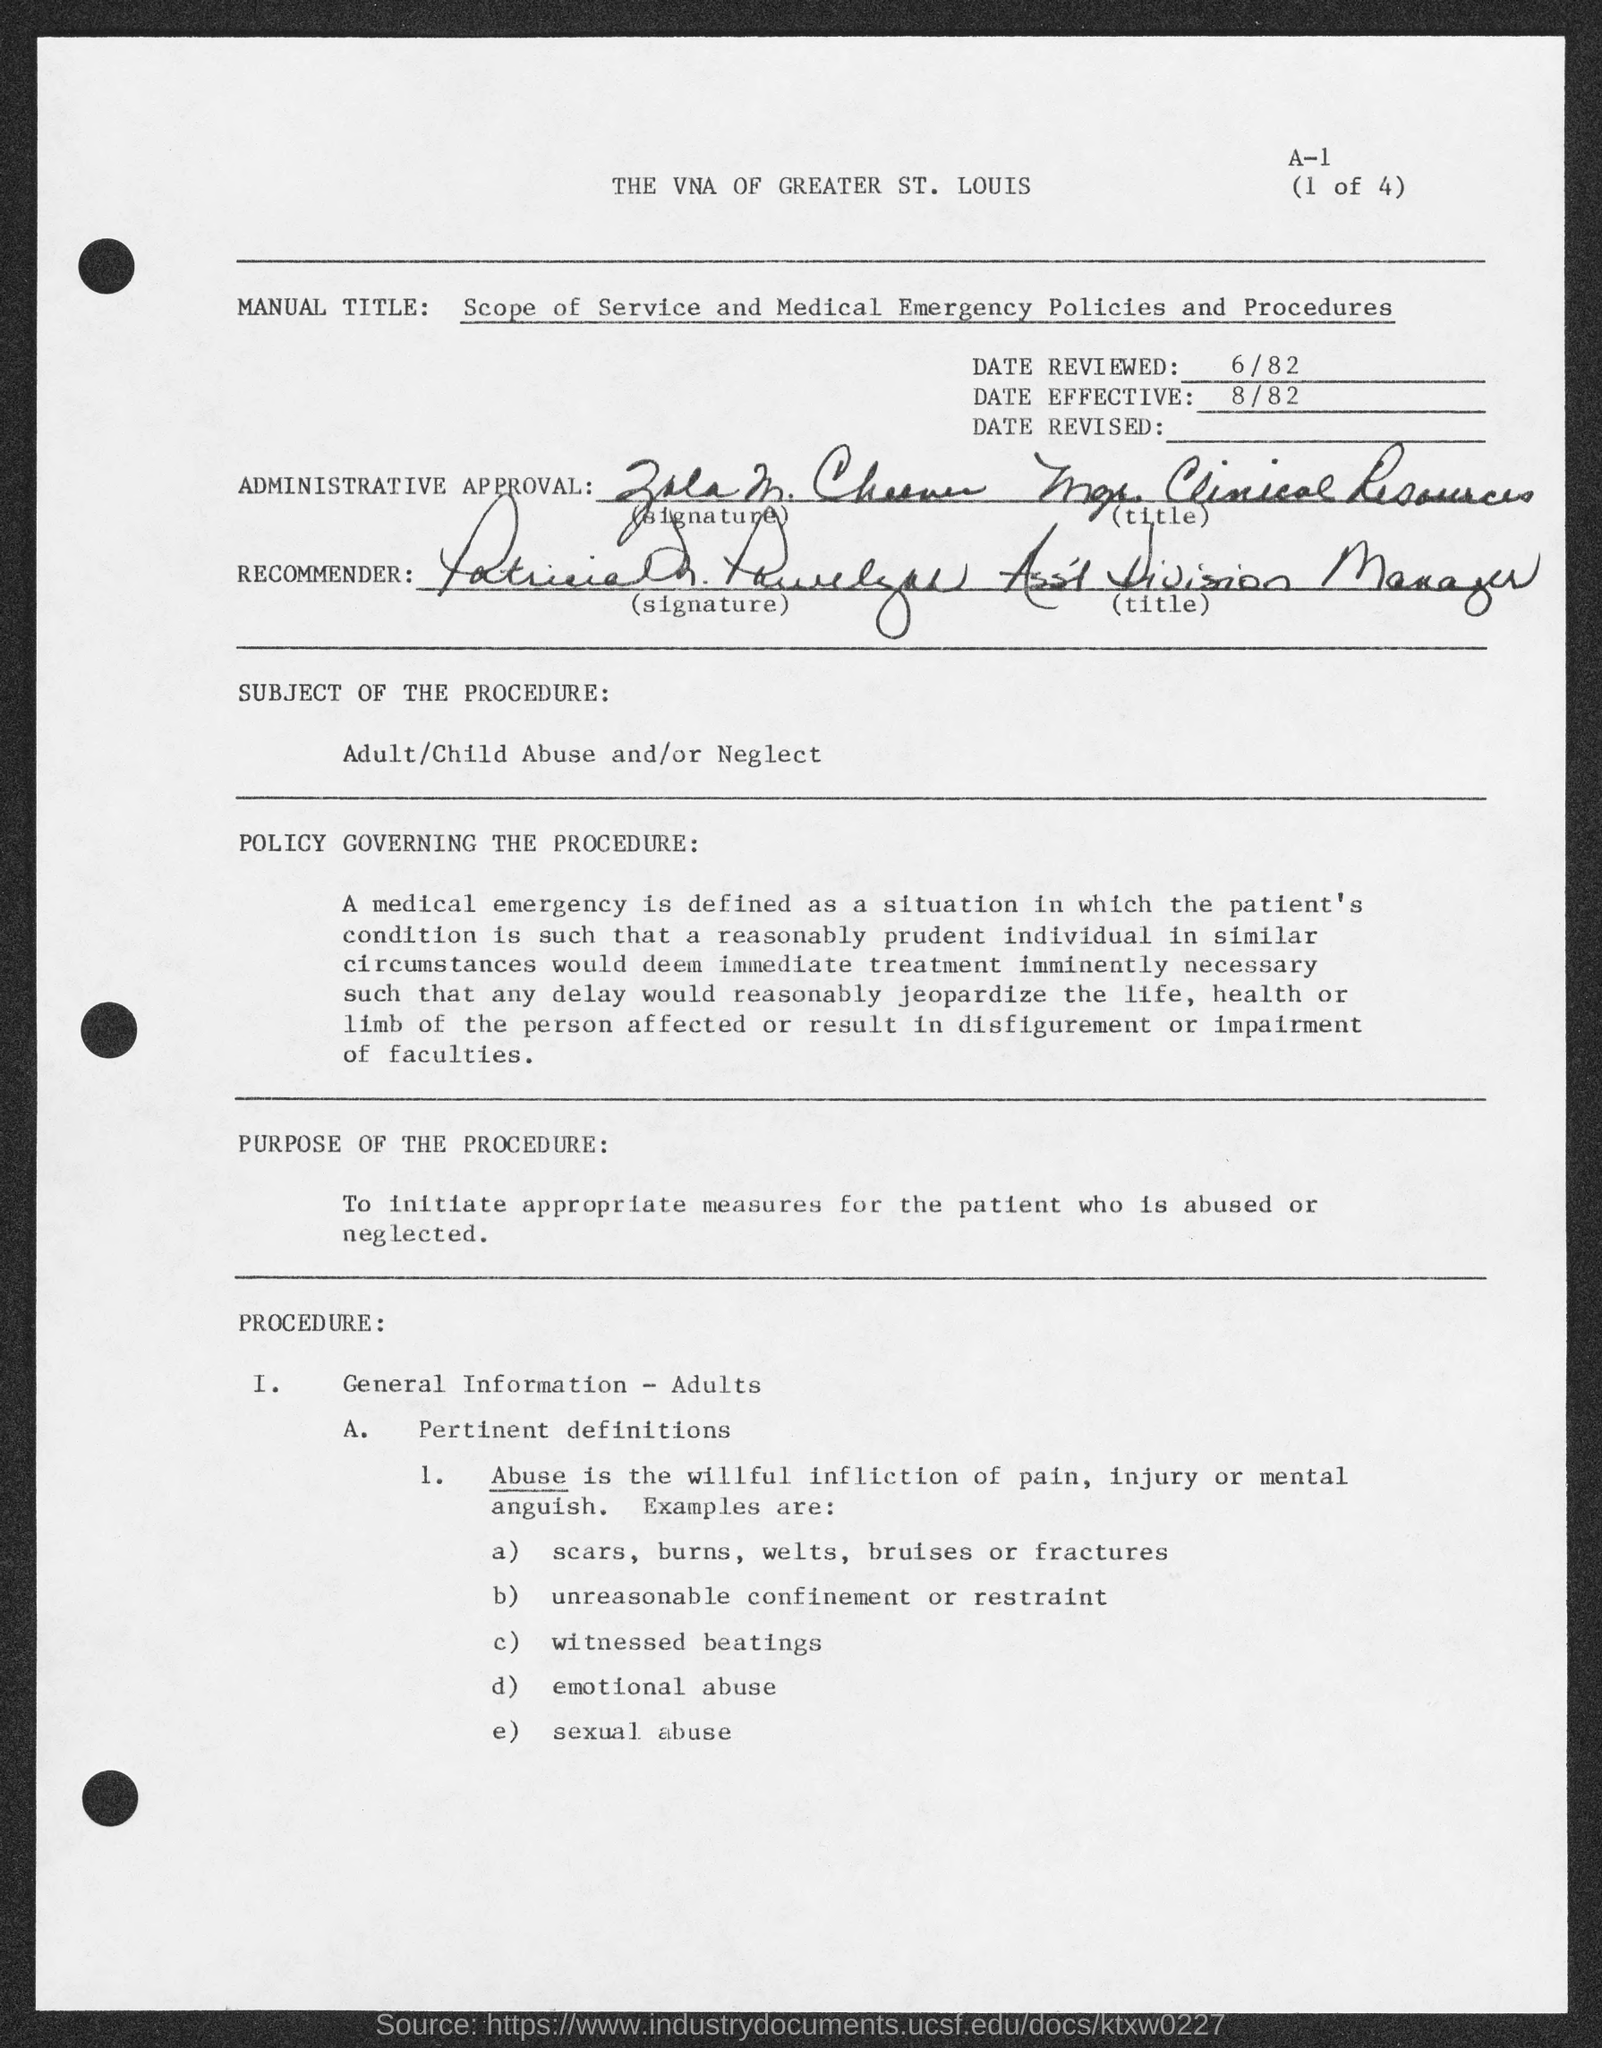What is the title of the document shown in the image? The title of the document is 'Scope of Service and Medical Emergency Policies and Procedures'. Can you summarize the purpose of this document? The document outlines the procedures for initiating appropriate measures for patients who are abused or neglected, as indicated by the 'PURPOSE OF THE PROCEDURE' section. 